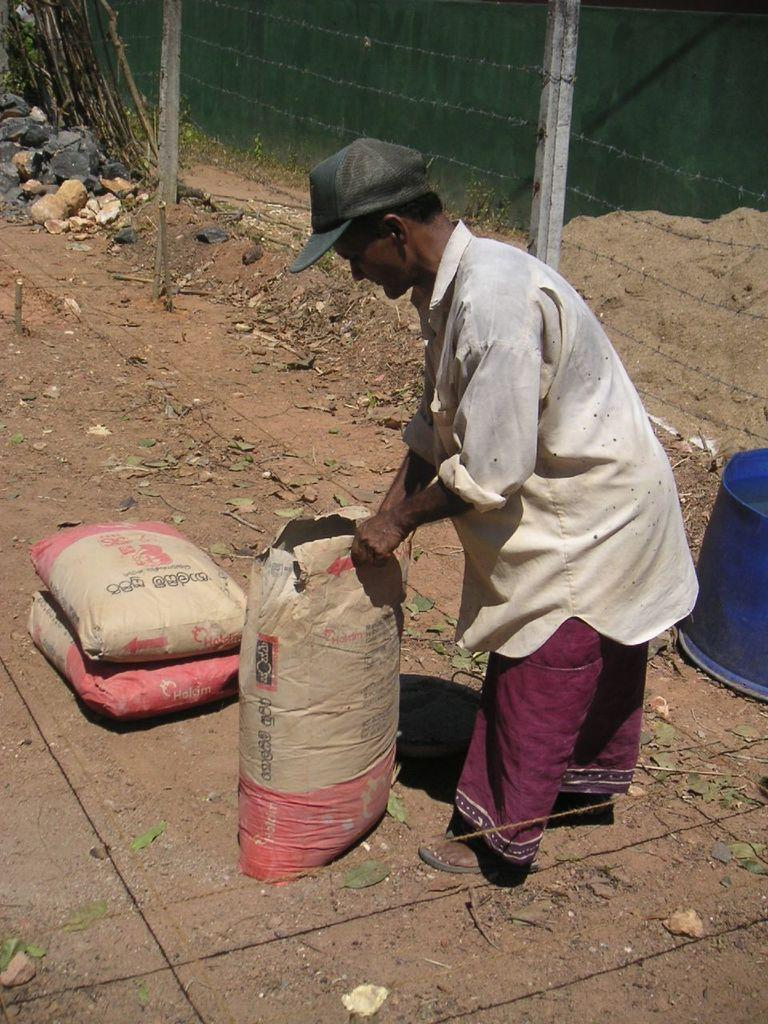Who is present in the image? There is a person in the image. What is the person wearing on their head? The person is wearing a cap. Can you describe any objects in the image? Yes, there are objects in the image, including an object on the right side. What type of fence is visible near the object on the right side? A barbed fence is visible near the object on the right side. then formulate questions that focus on the location and characteristics of these subjects and objects, ensuring that each question can be answered definitively with the information given. We avoid yes/no questions and ensure that the language is simple and clear. What book is the person reading in the image? There is no book or reading activity present in the image. What type of aircraft can be seen at the airport in the image? There is no airport or aircraft visible in the image. 